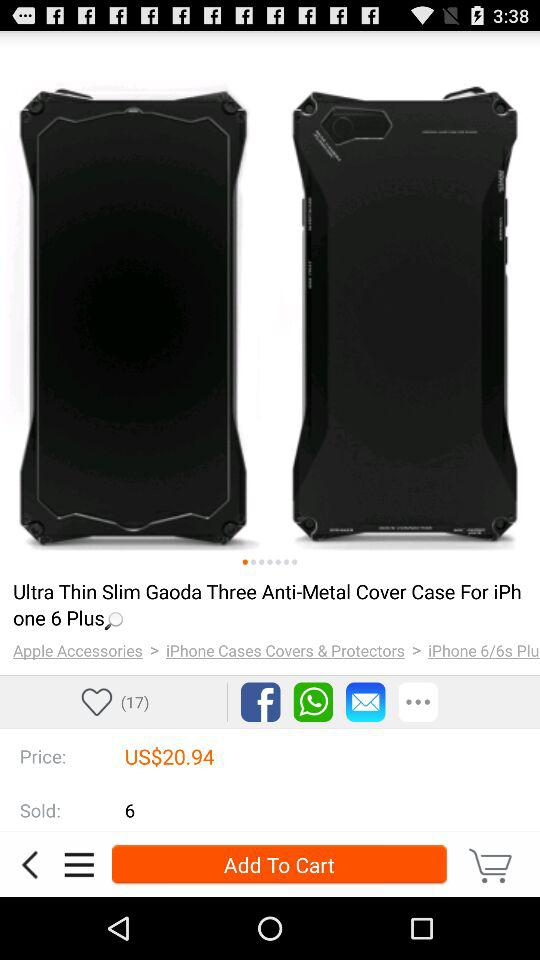How many "Anti-Metal Cover" have been sold till now? There are 6 "Anti-Metal Cover" that have been sold till now. 